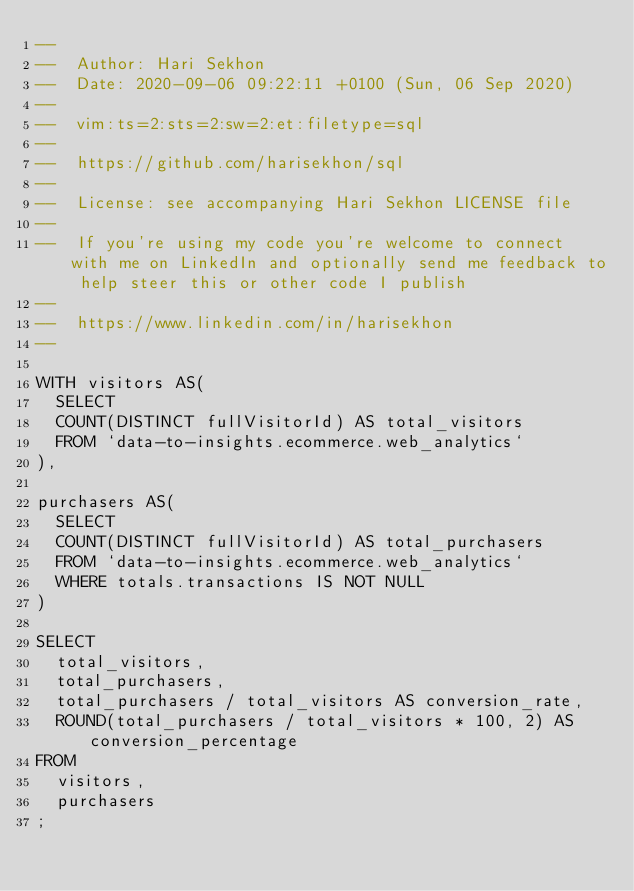Convert code to text. <code><loc_0><loc_0><loc_500><loc_500><_SQL_>--
--  Author: Hari Sekhon
--  Date: 2020-09-06 09:22:11 +0100 (Sun, 06 Sep 2020)
--
--  vim:ts=2:sts=2:sw=2:et:filetype=sql
--
--  https://github.com/harisekhon/sql
--
--  License: see accompanying Hari Sekhon LICENSE file
--
--  If you're using my code you're welcome to connect with me on LinkedIn and optionally send me feedback to help steer this or other code I publish
--
--  https://www.linkedin.com/in/harisekhon
--

WITH visitors AS(
  SELECT
  COUNT(DISTINCT fullVisitorId) AS total_visitors
  FROM `data-to-insights.ecommerce.web_analytics`
),

purchasers AS(
  SELECT
  COUNT(DISTINCT fullVisitorId) AS total_purchasers
  FROM `data-to-insights.ecommerce.web_analytics`
  WHERE totals.transactions IS NOT NULL
)

SELECT
  total_visitors,
  total_purchasers,
  total_purchasers / total_visitors AS conversion_rate,
  ROUND(total_purchasers / total_visitors * 100, 2) AS conversion_percentage
FROM
  visitors,
  purchasers
;
</code> 